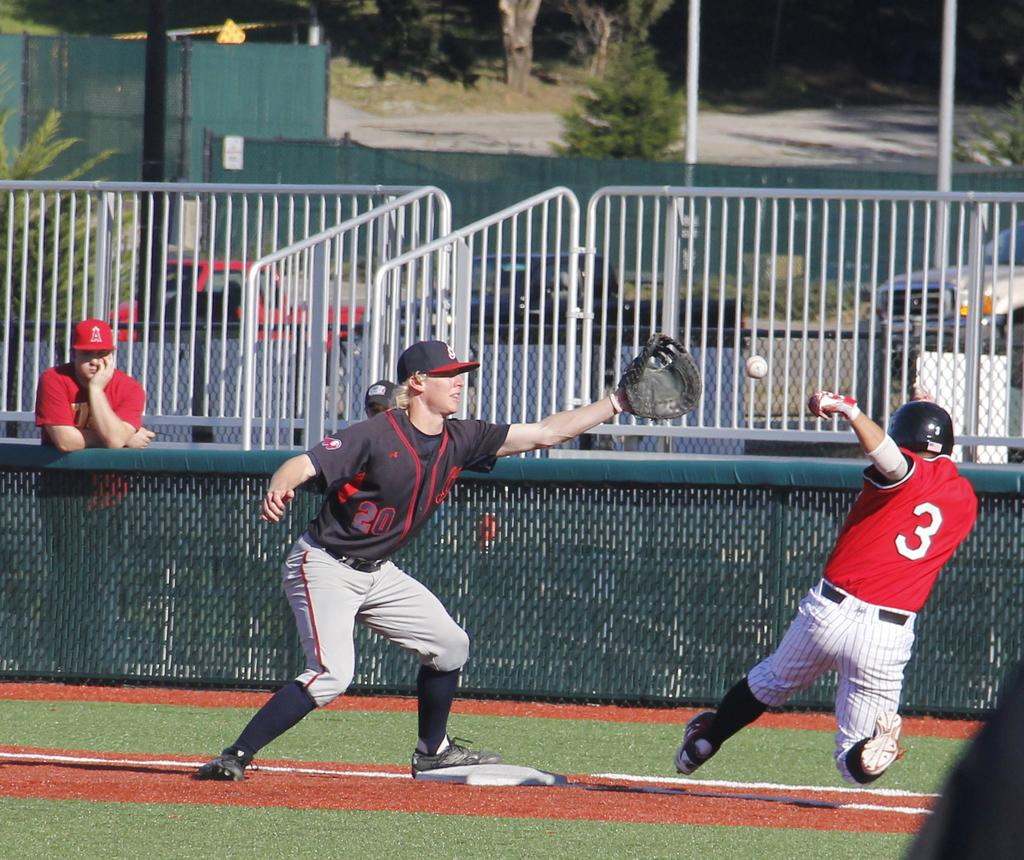Provide a one-sentence caption for the provided image. First baseman with no 20 is readying to catch the ball as the batter rushes the base. 